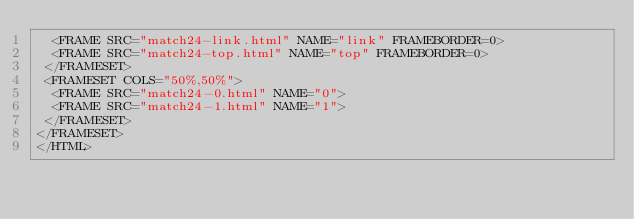<code> <loc_0><loc_0><loc_500><loc_500><_HTML_>  <FRAME SRC="match24-link.html" NAME="link" FRAMEBORDER=0>
  <FRAME SRC="match24-top.html" NAME="top" FRAMEBORDER=0>
 </FRAMESET>
 <FRAMESET COLS="50%,50%">
  <FRAME SRC="match24-0.html" NAME="0">
  <FRAME SRC="match24-1.html" NAME="1">
 </FRAMESET>
</FRAMESET>
</HTML>
</code> 